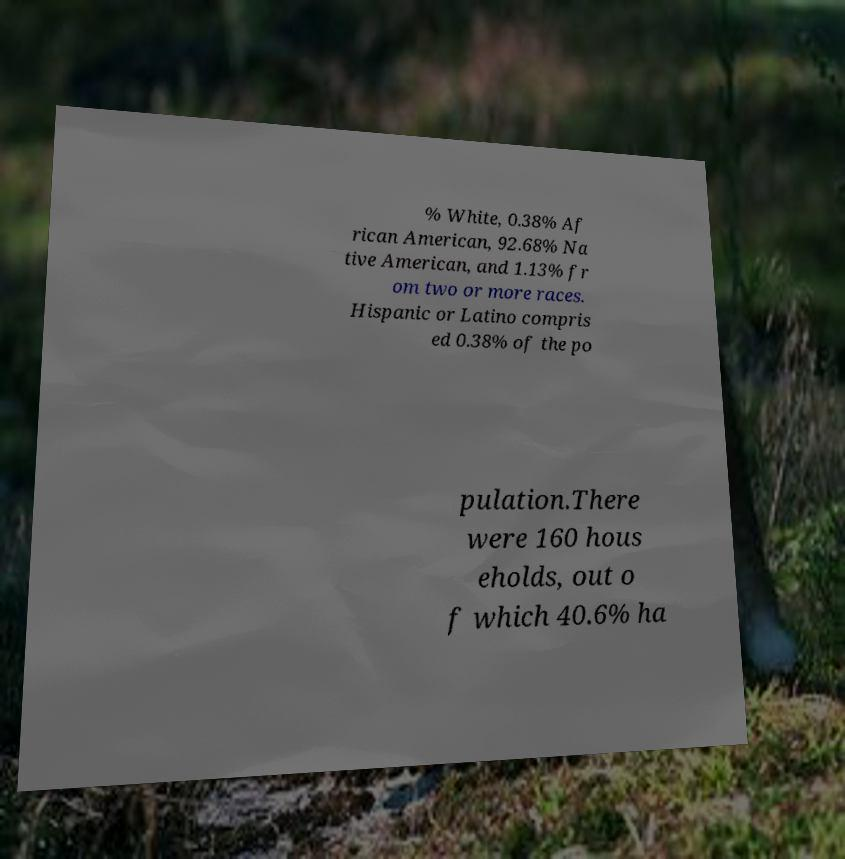There's text embedded in this image that I need extracted. Can you transcribe it verbatim? % White, 0.38% Af rican American, 92.68% Na tive American, and 1.13% fr om two or more races. Hispanic or Latino compris ed 0.38% of the po pulation.There were 160 hous eholds, out o f which 40.6% ha 